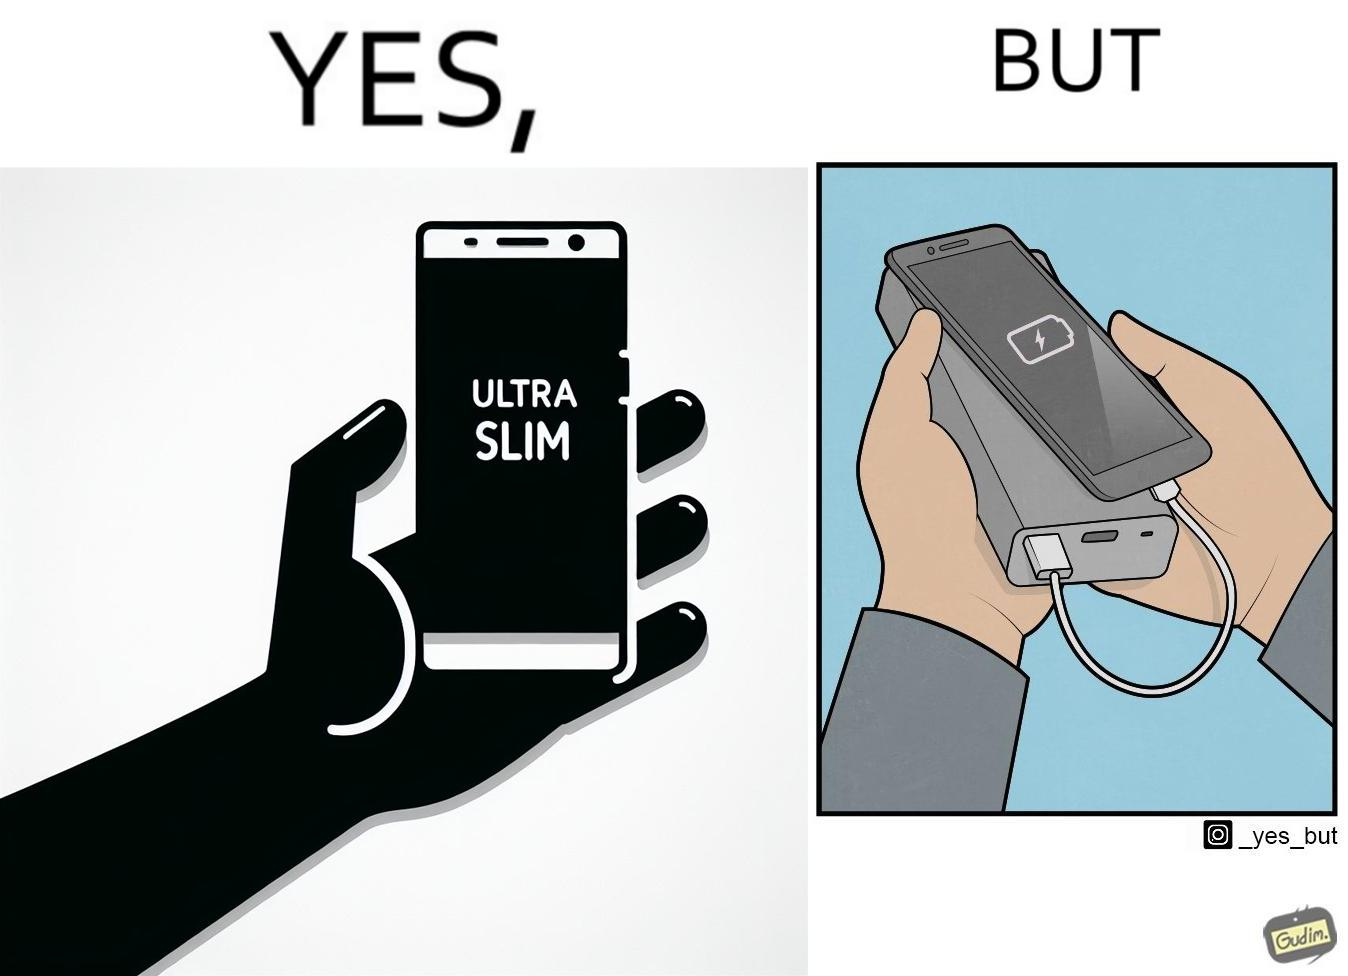Describe the content of this image. The image is satirical because even though the mobile phone has been developed to be very slim, it requires frequent recharging which makes the mobile phone useless without a big, heavy and thick power bank. 